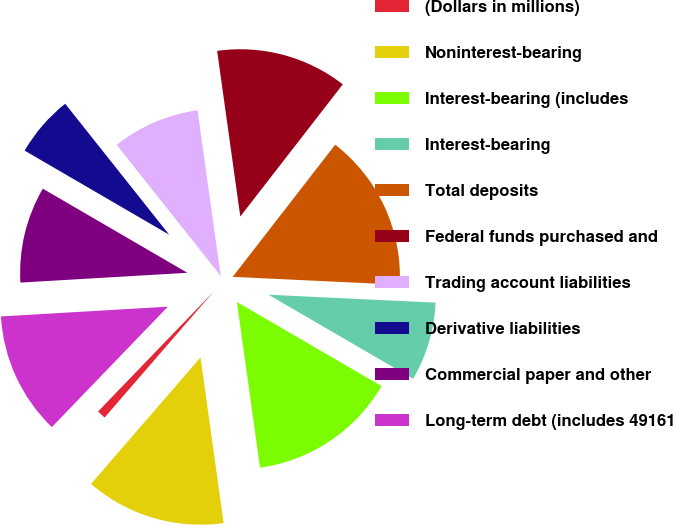Convert chart to OTSL. <chart><loc_0><loc_0><loc_500><loc_500><pie_chart><fcel>(Dollars in millions)<fcel>Noninterest-bearing<fcel>Interest-bearing (includes<fcel>Interest-bearing<fcel>Total deposits<fcel>Federal funds purchased and<fcel>Trading account liabilities<fcel>Derivative liabilities<fcel>Commercial paper and other<fcel>Long-term debt (includes 49161<nl><fcel>0.85%<fcel>13.56%<fcel>14.41%<fcel>7.63%<fcel>15.25%<fcel>12.71%<fcel>8.47%<fcel>5.93%<fcel>9.32%<fcel>11.86%<nl></chart> 